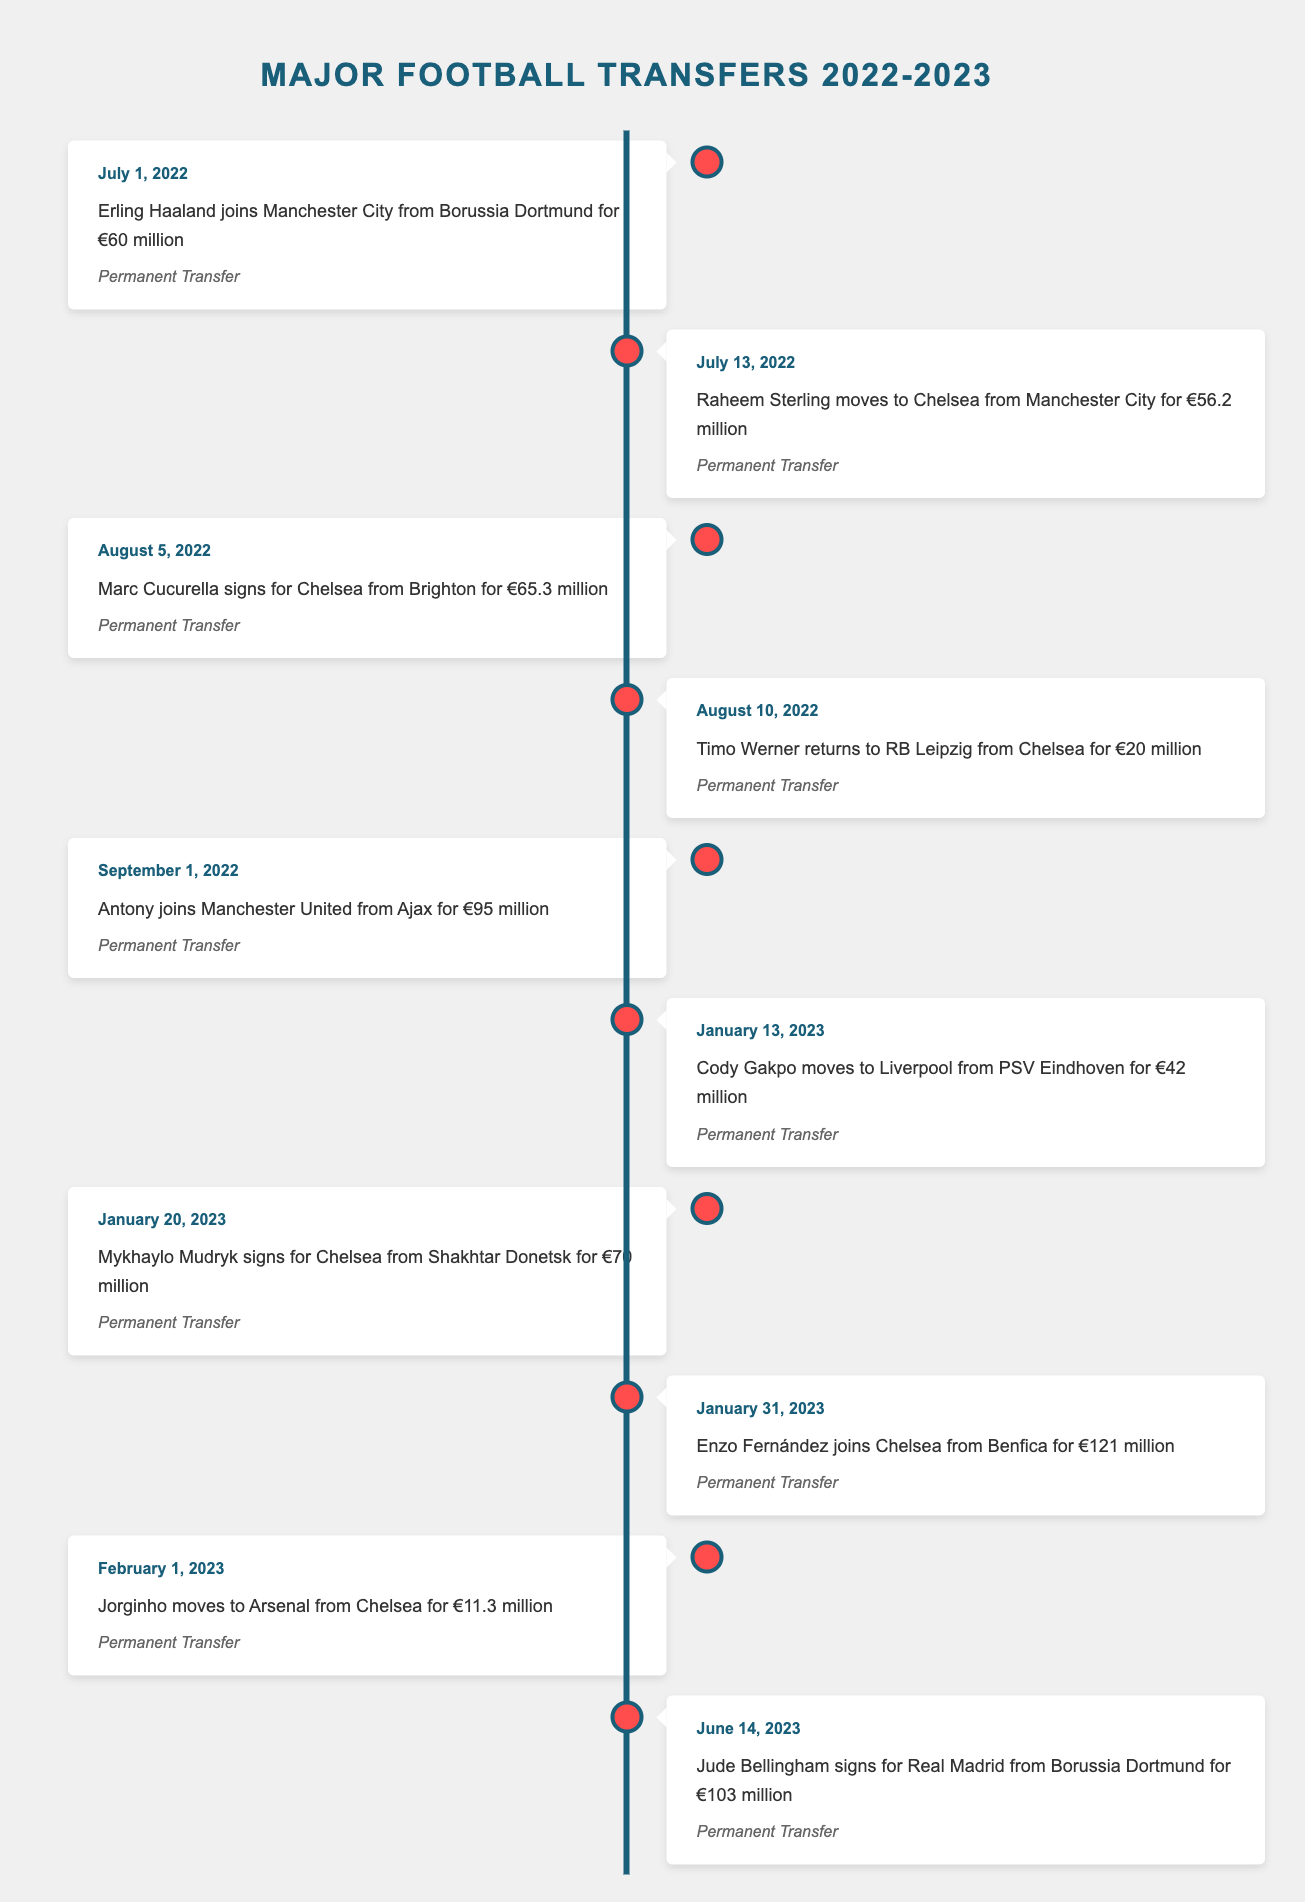What is the date when Erling Haaland joined Manchester City? The table shows that Erling Haaland joined Manchester City on July 1, 2022.
Answer: July 1, 2022 How much did Antony transfer to Manchester United for? According to the table, Antony joined Manchester United from Ajax for €95 million.
Answer: €95 million Which player moved from Chelsea to Arsenal in February 2023? The table indicates that Jorginho transferred from Chelsea to Arsenal on February 1, 2023.
Answer: Jorginho What is the total amount spent by Chelsea on players in this transfer window? Chelsea acquired three players: Marc Cucurella for €65.3 million, Mykhaylo Mudryk for €70 million, and Enzo Fernández for €121 million. Adding these amounts gives €65.3 + €70 + €121 = €256.3 million total.
Answer: €256.3 million Did any player return to their former club during the 2022-2023 season? Yes, Timo Werner returned to RB Leipzig from Chelsea, as stated in the table.
Answer: Yes Which clubs were involved in the most transfer activities according to the table? The table shows multiple players moving to and from Chelsea, indicating that they were significantly involved in transfers, along with Manchester City and Borussia Dortmund. Chelsea had several notable transfers, specifically: Raheem Sterling, Marc Cucurella, Timo Werner, Mykhaylo Mudryk, and Enzo Fernández.
Answer: Chelsea, Manchester City, Borussia Dortmund What was the average transfer fee for the five Chelsea players listed in the table? The transfer fees for the Chelsea players are €56.2 million, €65.3 million, €20 million, €70 million, and €121 million. Adding these amounts gives €332.5 million, and dividing by the number of transfers (5) gives an average of €332.5 million / 5 = €66.5 million.
Answer: €66.5 million Is there only one player that moved from Chelsea to another club during this season? No, multiple players moved from Chelsea, including Raheem Sterling, Timo Werner, and Jorginho, indicating more than one transfer.
Answer: No Which player had the highest transfer fee in the 2022-2023 season? The table shows that Enzo Fernández joined Chelsea for €121 million, the highest transfer fee listed in the data.
Answer: Enzo Fernández 